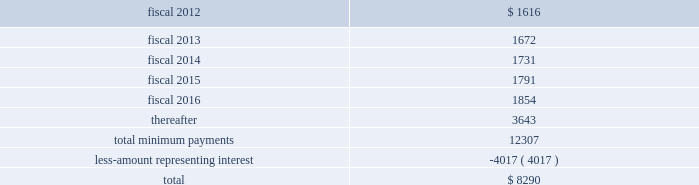Table of contents finance lease obligations the company has a non-cancelable lease agreement for a building with approximately 164000 square feet located in alajuela , costa rica , to be used as a manufacturing and office facility .
The company was responsible for a significant portion of the construction costs , and in accordance with asc 840 , leases , subsection 40-15-5 , the company was deemed to be the owner of the building during the construction period .
The building was completed in fiscal 2008 , and the company has recorded the fair market value of the building and land of $ 15.1 million within property and equipment on its consolidated balance sheets .
At september 24 , 2011 , the company has recorded $ 1.6 million in accrued expenses and $ 16.9 million in other long-term liabilities related to this obligation in the consolidated balance sheet .
The term of the lease , which commenced in may 2008 , is for a period of approximately ten years with the option to extend for two consecutive 5-year terms .
At the completion of the construction period , the company reviewed the lease for potential sale-leaseback treatment in accordance with asc 840 , subsection 40 , sale-leaseback transactions .
Based on its analysis , the company determined that the lease did not qualify for sale-leaseback treatment .
Therefore , the building , leasehold improvements and associated liabilities remain on the company 2019s financial statements throughout the lease term , and the building and leasehold improvements are being depreciated on a straight line basis over their estimated useful lives of 35 years .
Future minimum lease payments , including principal and interest , under this lease were as follows at september 24 , 2011: .
The company also has to a non-cancelable lease agreement for a building with approximately 146000 square feet located in marlborough , massachusetts , to be principally used as an additional manufacturing facility .
As part of the lease agreement , the lessor agreed to allow the company to make significant renovations to the facility to prepare the facility for the company 2019s manufacturing needs .
The company was responsible for a significant amount of the construction costs and therefore in accordance with asc 840-40-15-5 was deemed to be the owner of the building during the construction period .
The $ 13.2 million fair market value of the facility is included within property and equipment on the consolidated balance sheet .
At september 24 , 2011 , the company has recorded $ 1.0 million in accrued expenses and $ 15.9 million in other long-term liabilities related to this obligation in the consolidated balance sheet .
The term of the lease is for a period of approximately 12 years commencing on november 14 , 2006 with the option to extend for two consecutive 5-year terms .
Based on its asc 840-40 analysis , the company determined that the lease did not qualify for sale-leaseback treatment .
Therefore , the improvements and associated liabilities will remain on the company 2019s financial statements throughout the lease term , and the leasehold improvements are being depreciated on a straight line basis over their estimated useful lives of up to 35 years .
Source : hologic inc , 10-k , november 23 , 2011 powered by morningstar ae document research 2120 the information contained herein may not be copied , adapted or distributed and is not warranted to be accurate , complete or timely .
The user assumes all risks for any damages or losses arising from any use of this information , except to the extent such damages or losses cannot be limited or excluded by applicable law .
Past financial performance is no guarantee of future results. .
What percent of future minimum lease payments are projected to be paid off in 2016? 
Rationale: to find the percent of future minimum lease payments one must divide the projected payments in 2016 by the total amount of payments
Computations: (1854 / 8290)
Answer: 0.22364. 